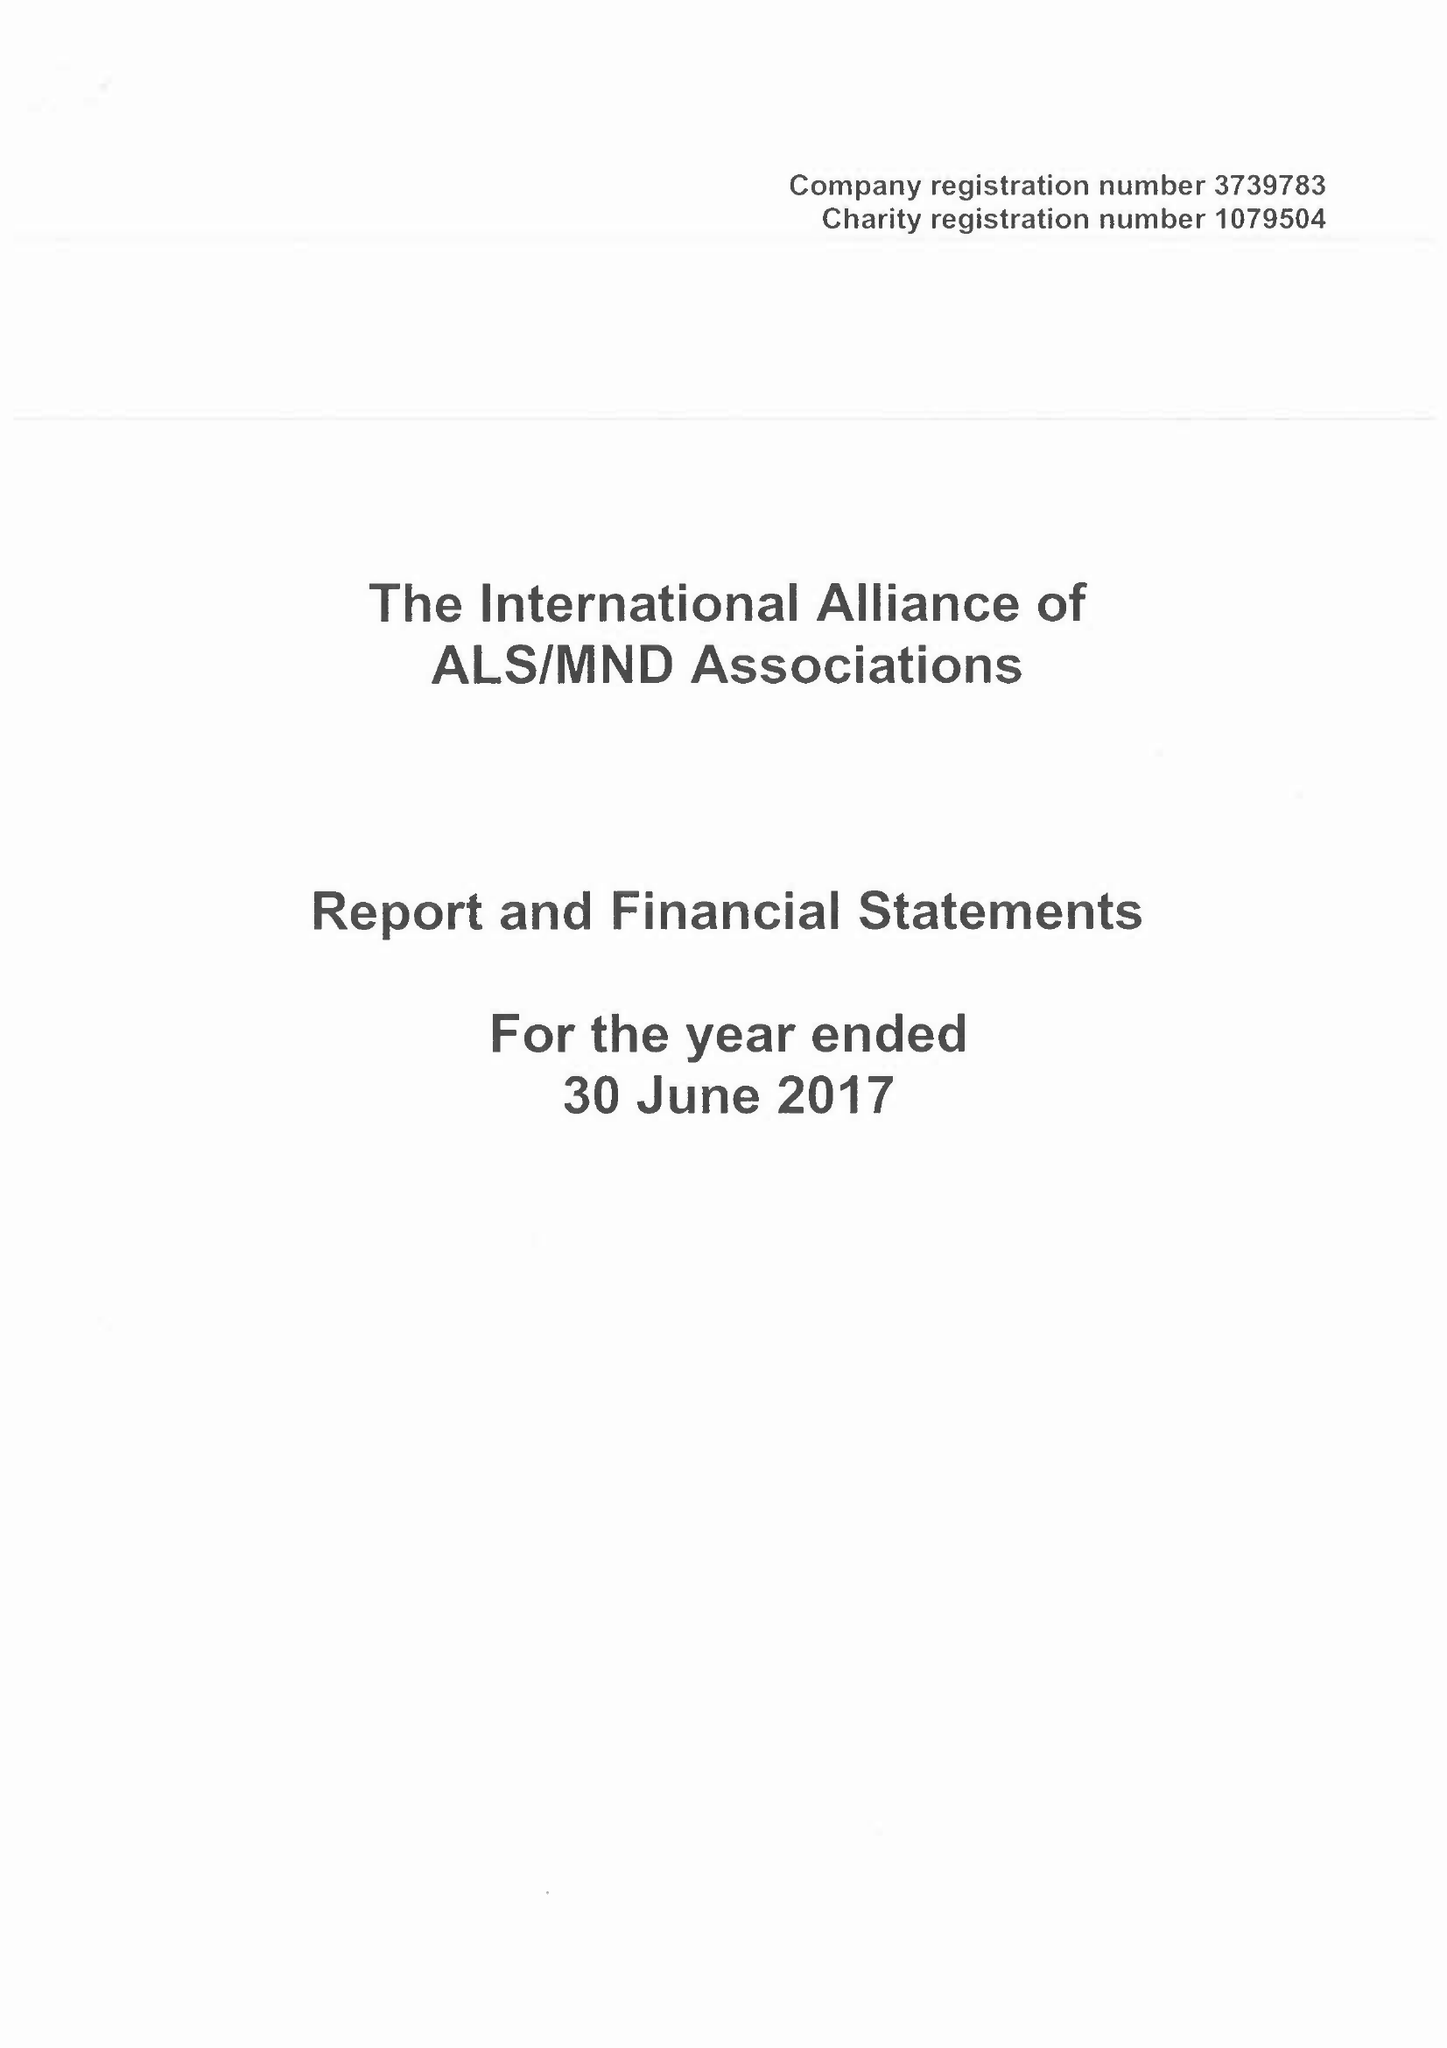What is the value for the address__postcode?
Answer the question using a single word or phrase. NN1 2BG 